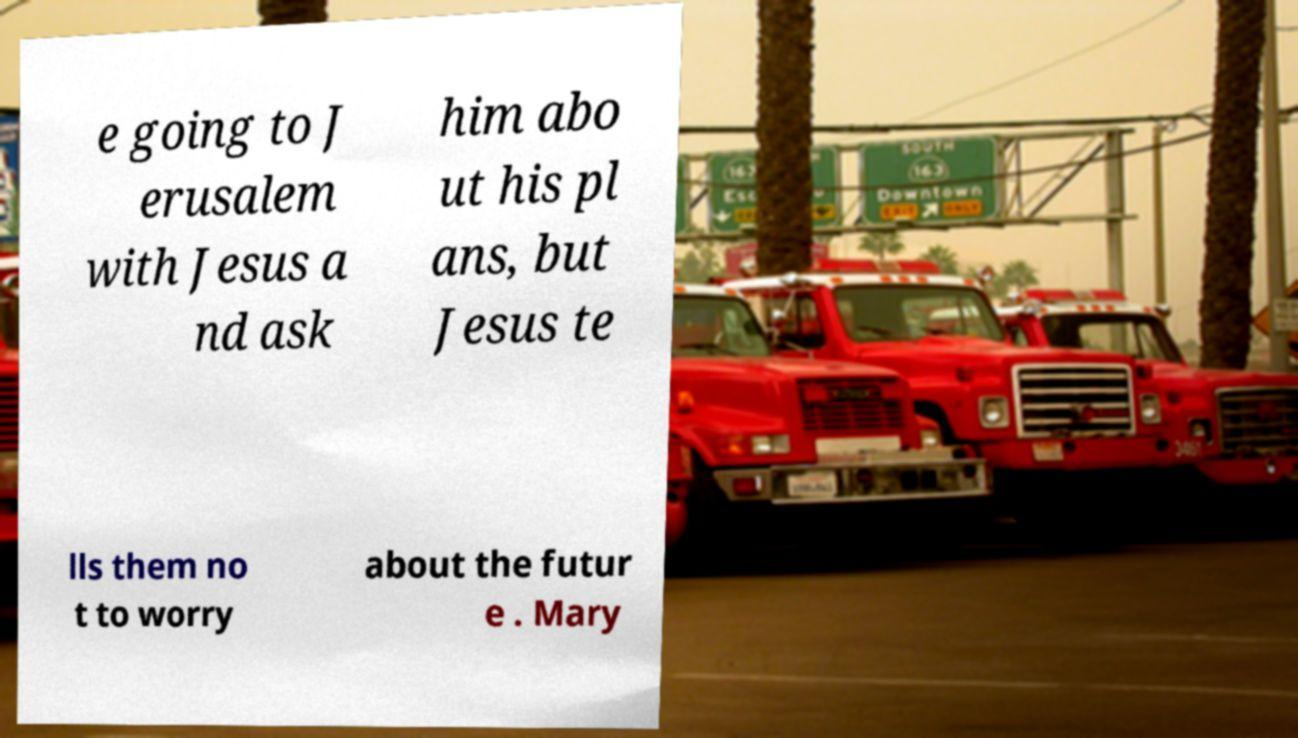For documentation purposes, I need the text within this image transcribed. Could you provide that? e going to J erusalem with Jesus a nd ask him abo ut his pl ans, but Jesus te lls them no t to worry about the futur e . Mary 